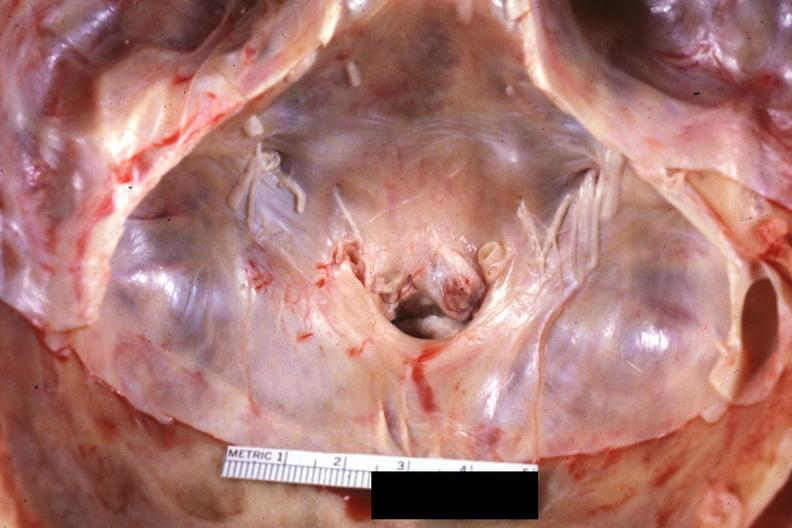does cervix duplication show close-up of foramen magnum stenosis due to subluxation of atlas vertebra case 31?
Answer the question using a single word or phrase. No 